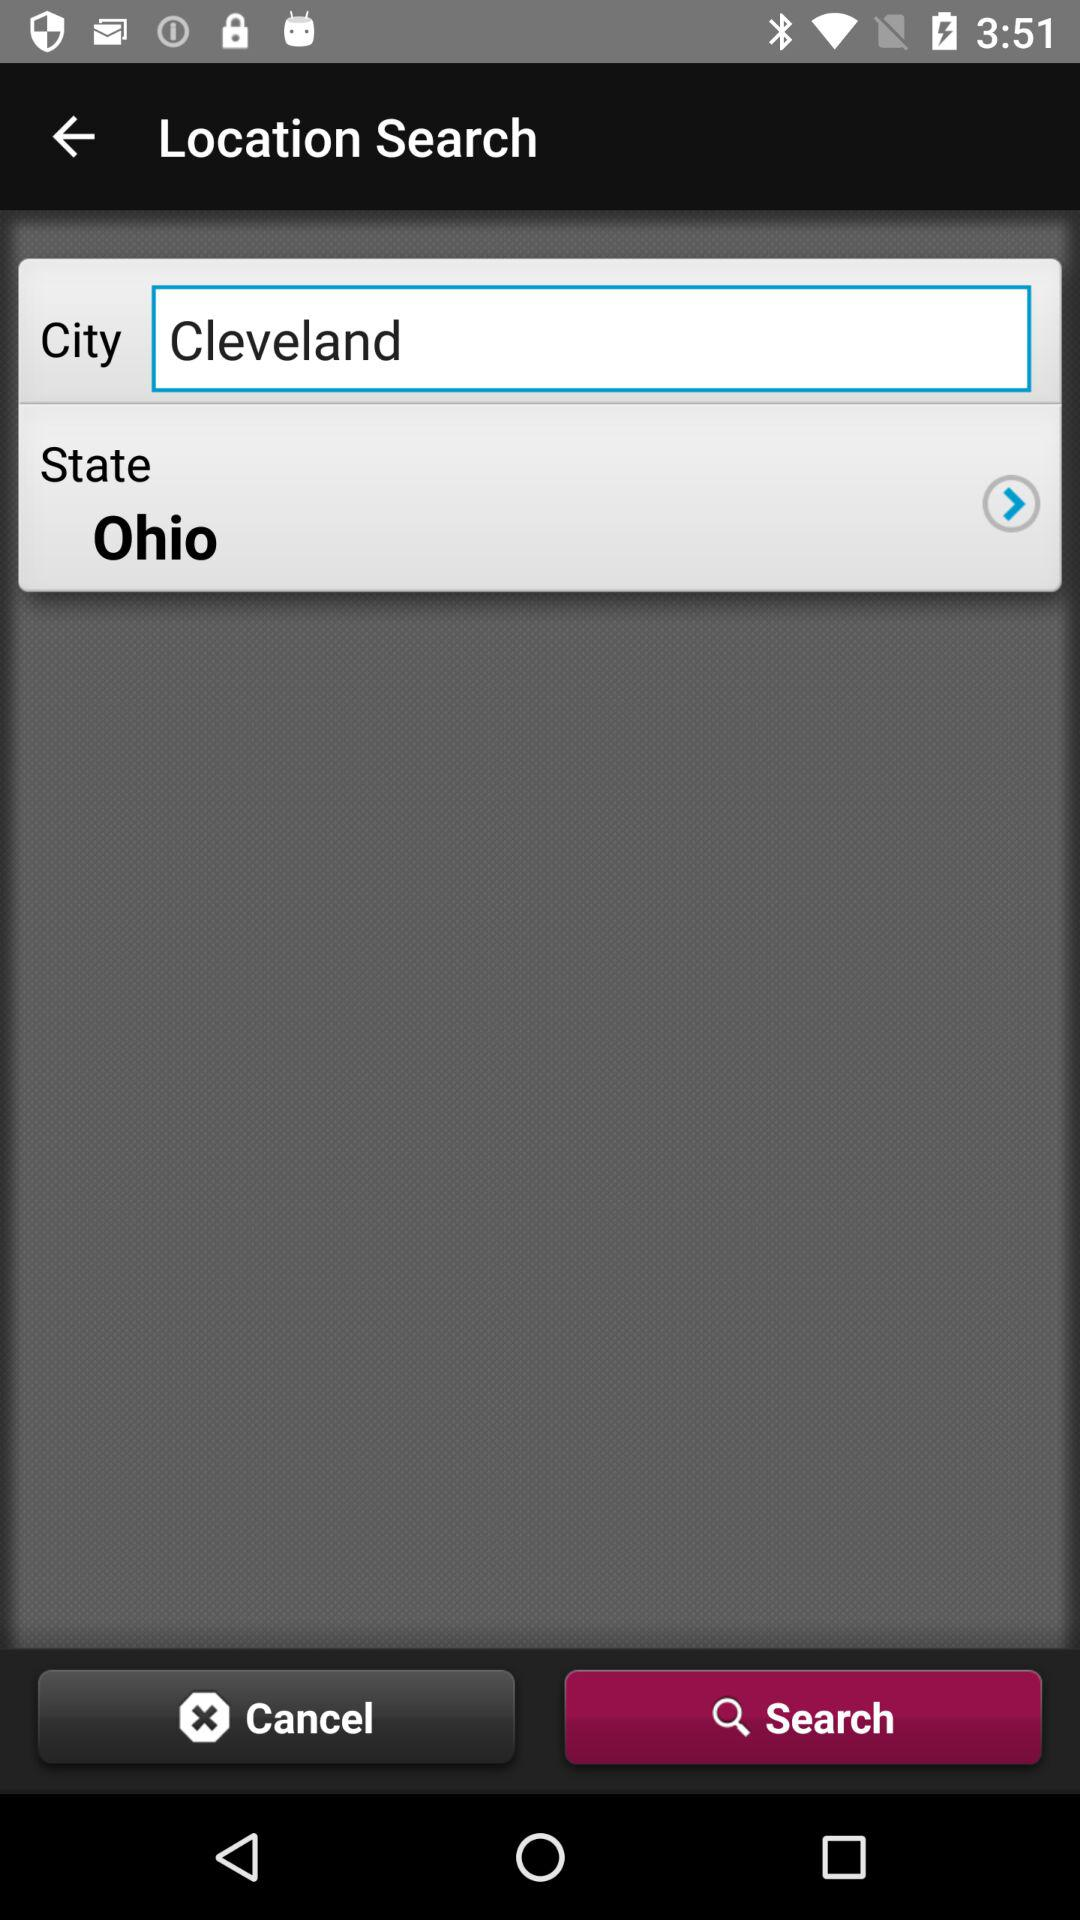What city is mentioned? The mentioned city is Cleveland. 